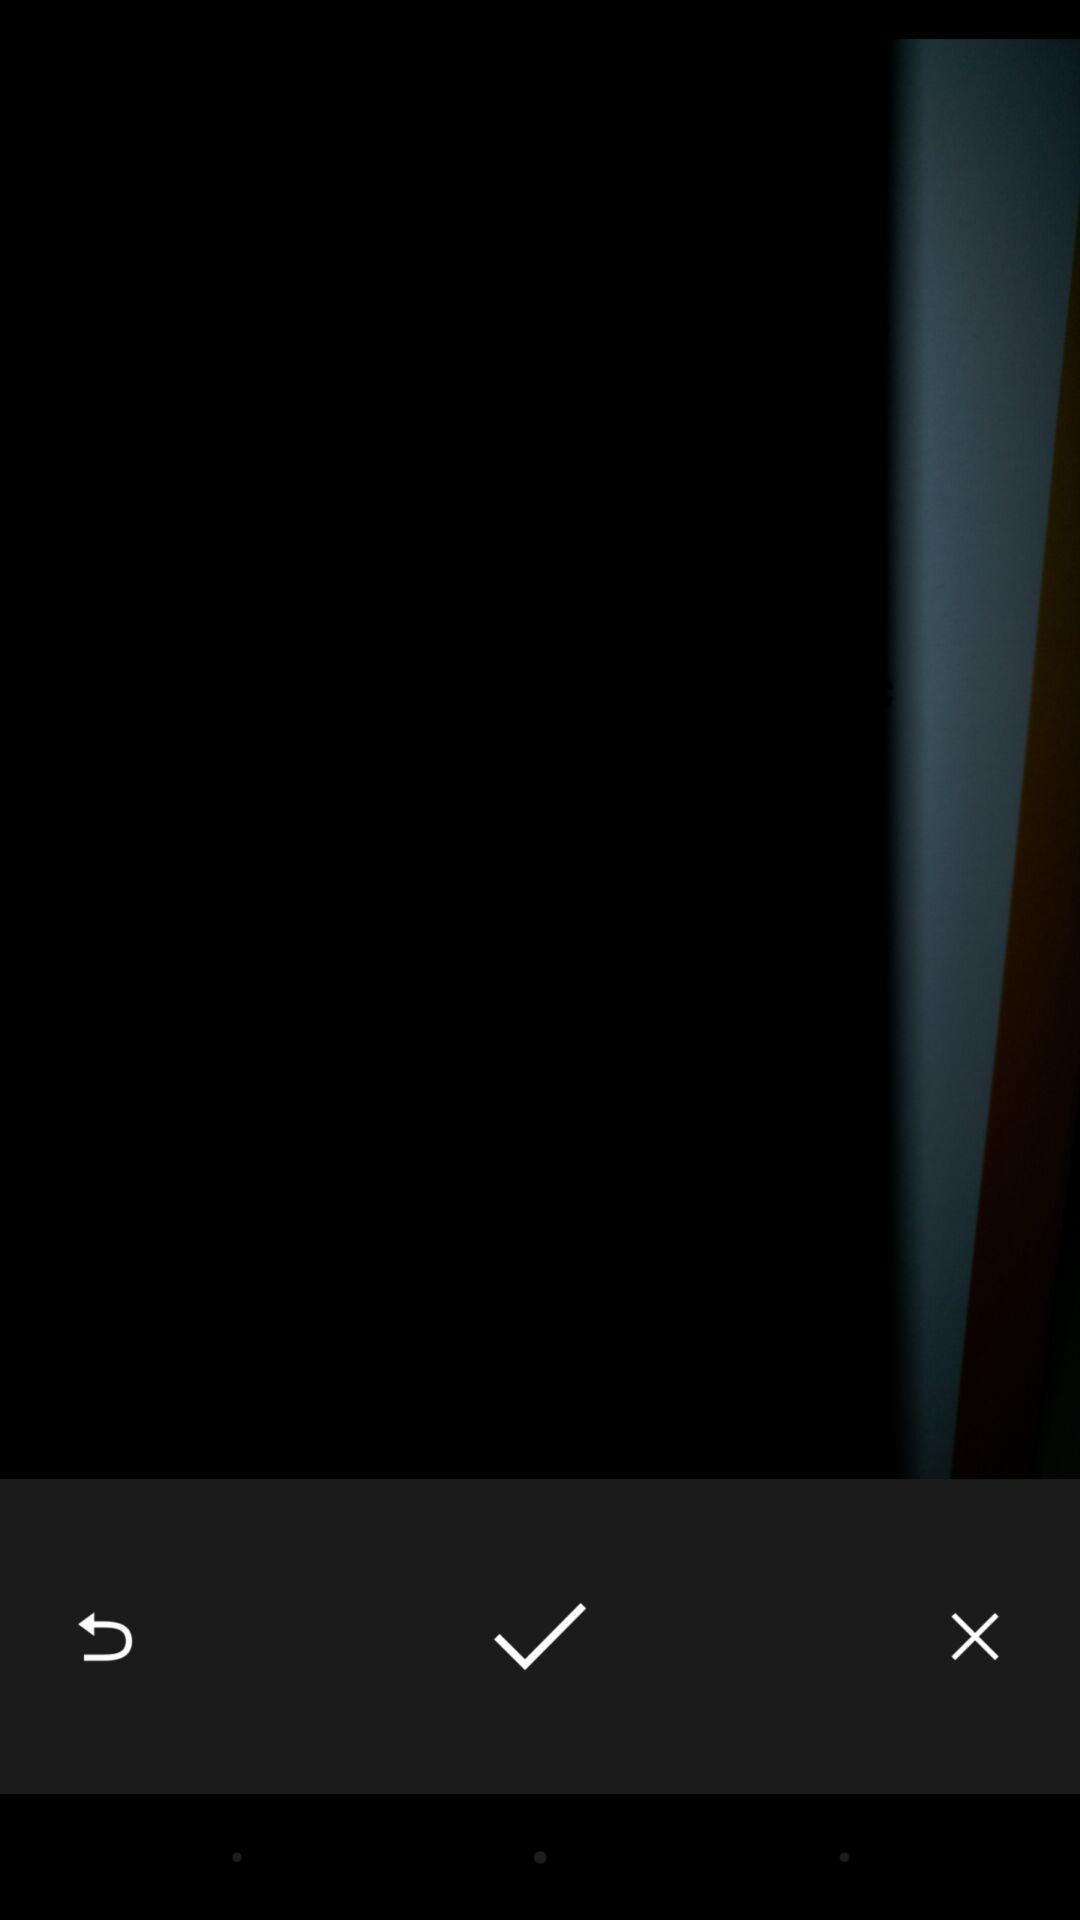Give me a summary of this screen capture. Screen shows zoomed image with multiple options. 